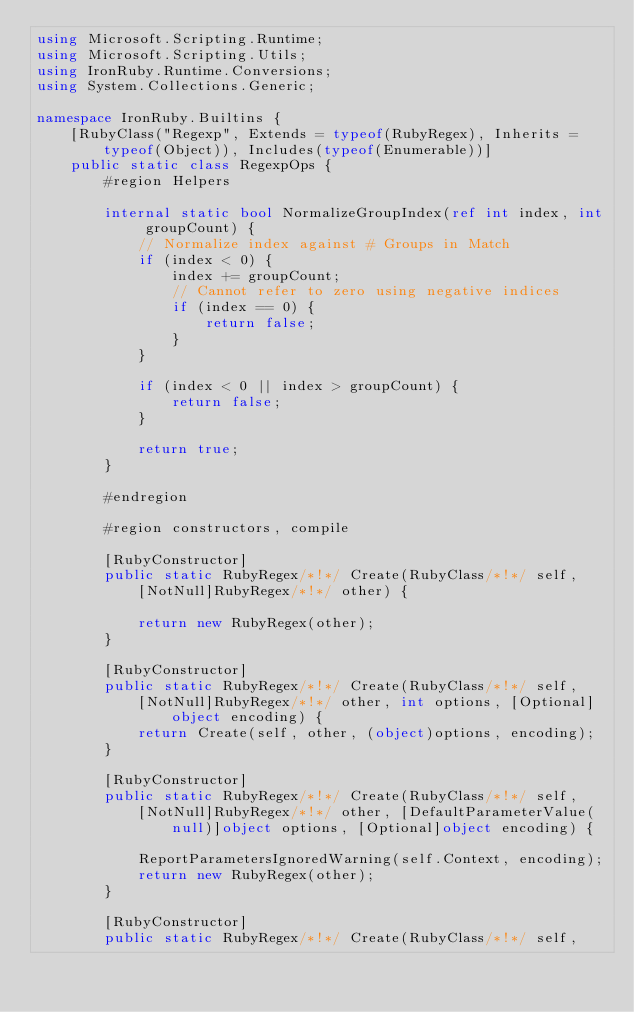Convert code to text. <code><loc_0><loc_0><loc_500><loc_500><_C#_>using Microsoft.Scripting.Runtime;
using Microsoft.Scripting.Utils;
using IronRuby.Runtime.Conversions;
using System.Collections.Generic;

namespace IronRuby.Builtins {
    [RubyClass("Regexp", Extends = typeof(RubyRegex), Inherits = typeof(Object)), Includes(typeof(Enumerable))]
    public static class RegexpOps {
        #region Helpers

        internal static bool NormalizeGroupIndex(ref int index, int groupCount) {
            // Normalize index against # Groups in Match
            if (index < 0) {
                index += groupCount;
                // Cannot refer to zero using negative indices 
                if (index == 0) {
                    return false;
                }
            }

            if (index < 0 || index > groupCount) {
                return false;
            }

            return true;
        }

        #endregion

        #region constructors, compile

        [RubyConstructor]
        public static RubyRegex/*!*/ Create(RubyClass/*!*/ self, 
            [NotNull]RubyRegex/*!*/ other) {
            
            return new RubyRegex(other);
        }

        [RubyConstructor]
        public static RubyRegex/*!*/ Create(RubyClass/*!*/ self,
            [NotNull]RubyRegex/*!*/ other, int options, [Optional]object encoding) {
            return Create(self, other, (object)options, encoding);
        }

        [RubyConstructor]
        public static RubyRegex/*!*/ Create(RubyClass/*!*/ self,
            [NotNull]RubyRegex/*!*/ other, [DefaultParameterValue(null)]object options, [Optional]object encoding) {

            ReportParametersIgnoredWarning(self.Context, encoding);
            return new RubyRegex(other);
        }
                
        [RubyConstructor]
        public static RubyRegex/*!*/ Create(RubyClass/*!*/ self,</code> 